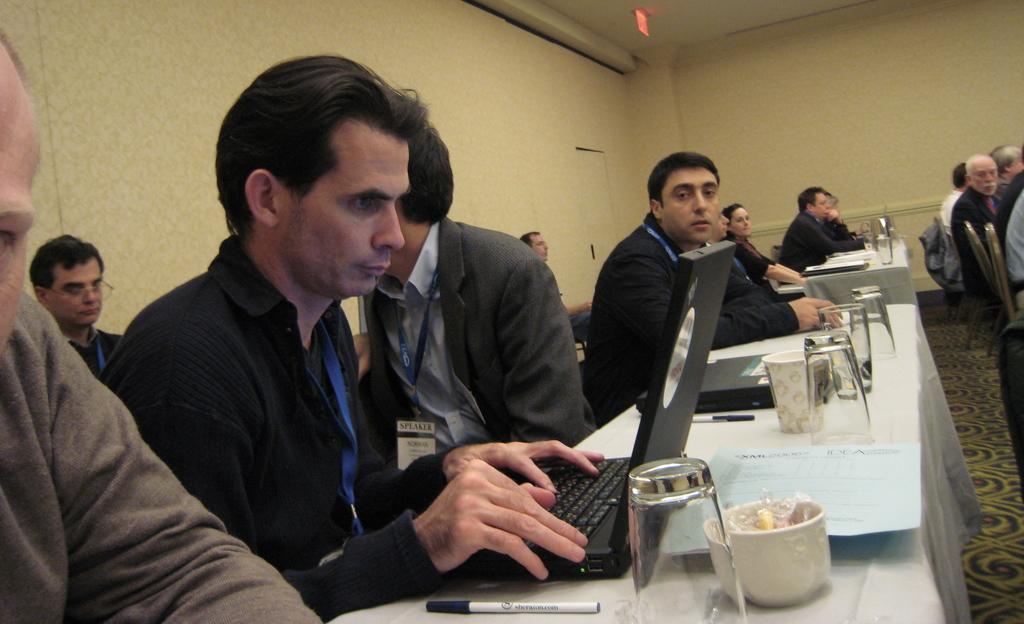Can you describe this image briefly? In this picture we can see a group of people sitting on chairs and in front of them we can see tables on the floor and on these tables we can see glasses, cups, laptops, clothespins and in the background we can see the walls. 